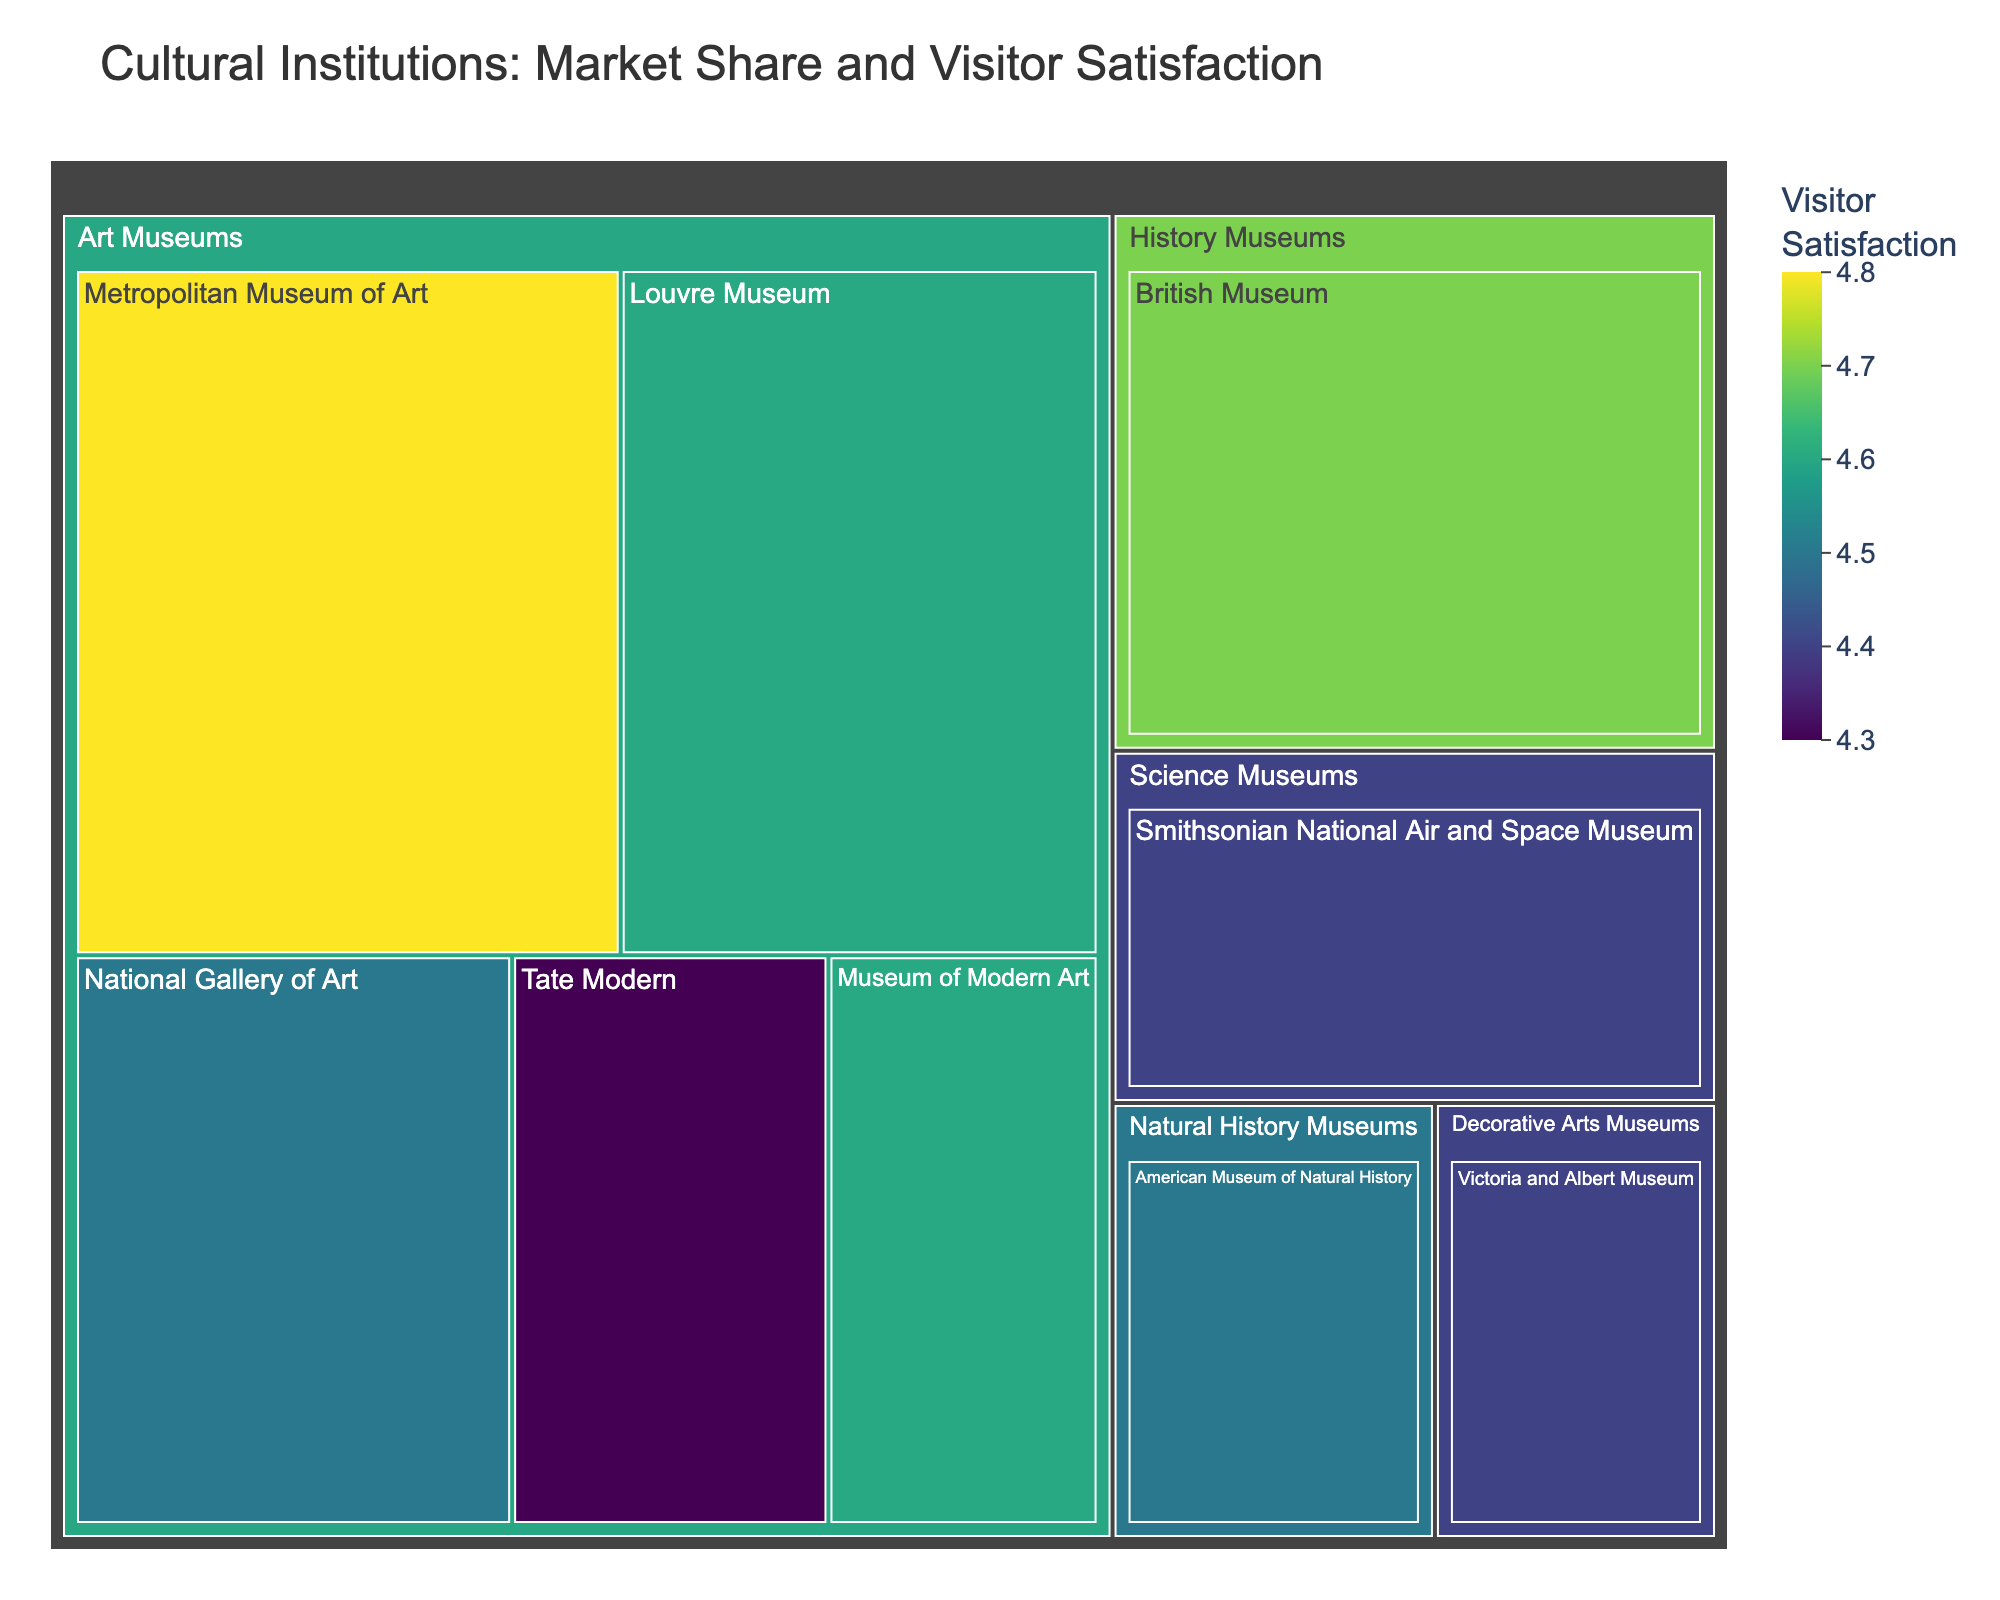Which institution has the highest market share? Look at the segments sized relatively to market share. The largest segment represents the institution with the highest market share, which is the Metropolitan Museum of Art.
Answer: Metropolitan Museum of Art Which institution has the highest visitor satisfaction rating? Look at the color intensity, where a higher rating corresponds to a more intense color. The brightest colored institution is the Metropolitan Museum of Art with a satisfaction rating of 4.8.
Answer: Metropolitan Museum of Art How many categories of cultural institutions are displayed? Count the top-level segments, representing different categories. These are Art Museums, History Museums, Science Museums, Natural History Museums, and Decorative Arts Museums.
Answer: 5 Which category has the most institutions listed? Identify and count the segments within each category. The Art Museums category has the most institutions, with a total of 6.
Answer: Art Museums What is the visitor satisfaction rating of the British Museum? Hovering over the British Museum segment reveals the visitor satisfaction rating of 4.7.
Answer: 4.7 What is the difference in market share between the Metropolitan Museum of Art and the Louvre Museum? Subtract the market share of the Louvre Museum (16.2) from that of the Metropolitan Museum of Art (18.5). The difference is 18.5 - 16.2 = 2.3.
Answer: 2.3 Compare the visitor satisfaction ratings between the National Gallery of Art and the Tate Modern. Which one is higher? Check the color intensity or hover over the segments to see the ratings. The National Gallery of Art has a rating of 4.5 compared to Tate Modern's 4.3, making it higher.
Answer: National Gallery of Art Which institution has the lowest market share among Art Museums? Compare the segments within the Art Museums category by their sizes. The smallest segment indicates the Museum of Modern Art with a market share of 7.6.
Answer: Museum of Modern Art What is the average visitor satisfaction across all institutions? Sum all the visitor satisfaction ratings and divide by the number of institutions: (4.8 + 4.6 + 4.7 + 4.5 + 4.4 + 4.3 + 4.6 + 4.5 + 4.4) / 9 = 4.533.
Answer: 4.533 Which institution within Science Museums has the highest visitor satisfaction? Science Museums category includes only the Smithsonian National Air and Space Museum, with a visitor satisfaction rating of 4.4.
Answer: Smithsonian National Air and Space Museum 